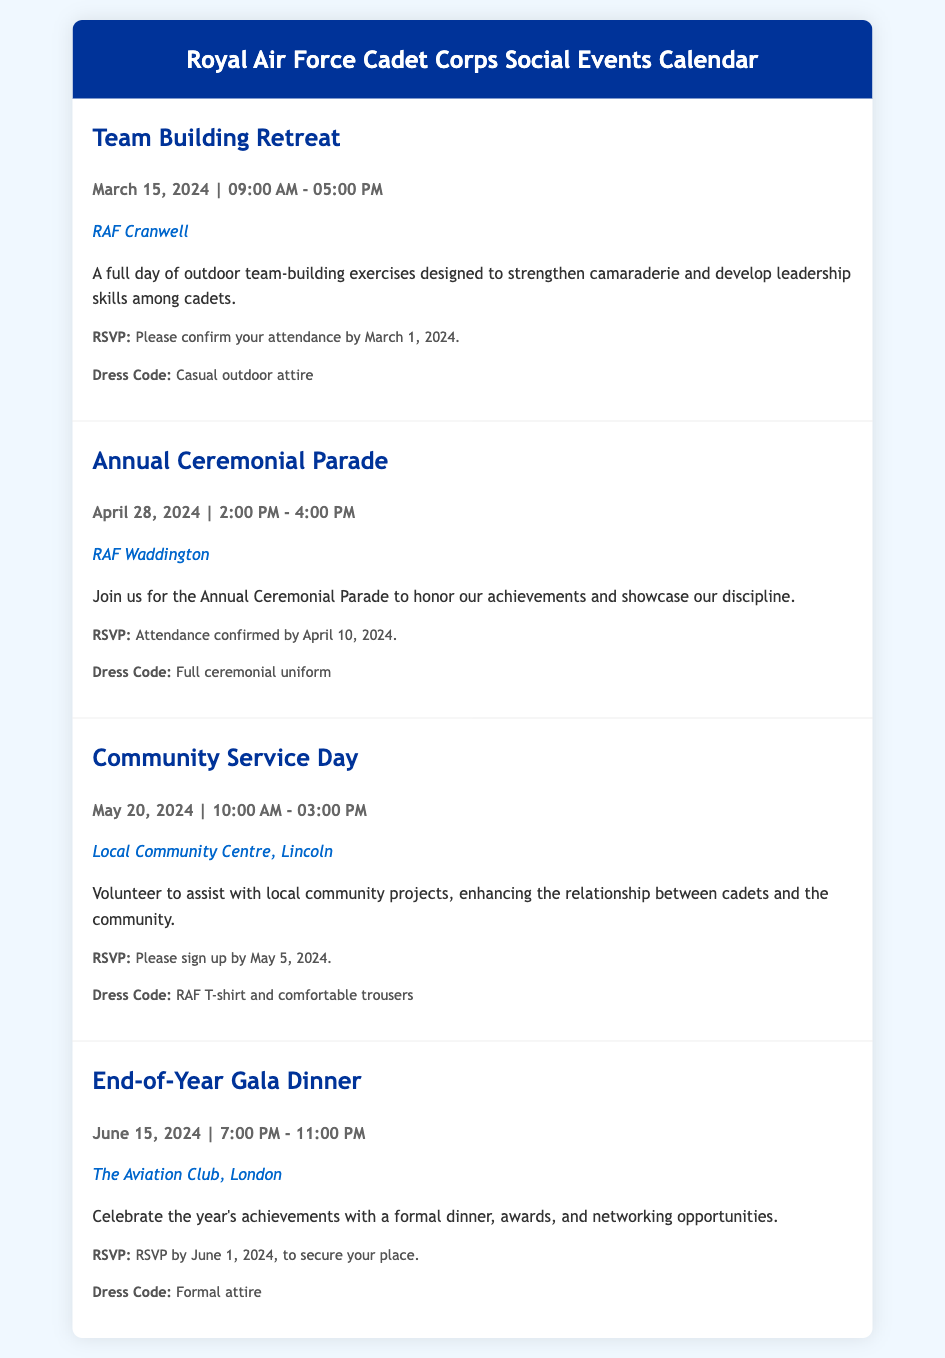What is the date of the Team Building Retreat? The Team Building Retreat is scheduled for March 15, 2024.
Answer: March 15, 2024 Where is the Annual Ceremonial Parade taking place? The Annual Ceremonial Parade will occur at RAF Waddington.
Answer: RAF Waddington What is the dress code for the Community Service Day? The dress code specified for the Community Service Day is RAF T-shirt and comfortable trousers.
Answer: RAF T-shirt and comfortable trousers What time does the End-of-Year Gala Dinner start? The End-of-Year Gala Dinner starts at 7:00 PM.
Answer: 7:00 PM When is the RSVP deadline for the Team Building Retreat? The RSVP for the Team Building Retreat is due by March 1, 2024.
Answer: March 1, 2024 How long is the Annual Ceremonial Parade? The Annual Ceremonial Parade is scheduled for 2 hours.
Answer: 2 hours What is the primary purpose of the Community Service Day? The primary purpose is to assist with local community projects.
Answer: Assist with local community projects What type of event is scheduled right before the End-of-Year Gala Dinner? The event scheduled before the End-of-Year Gala Dinner is Community Service Day.
Answer: Community Service Day 